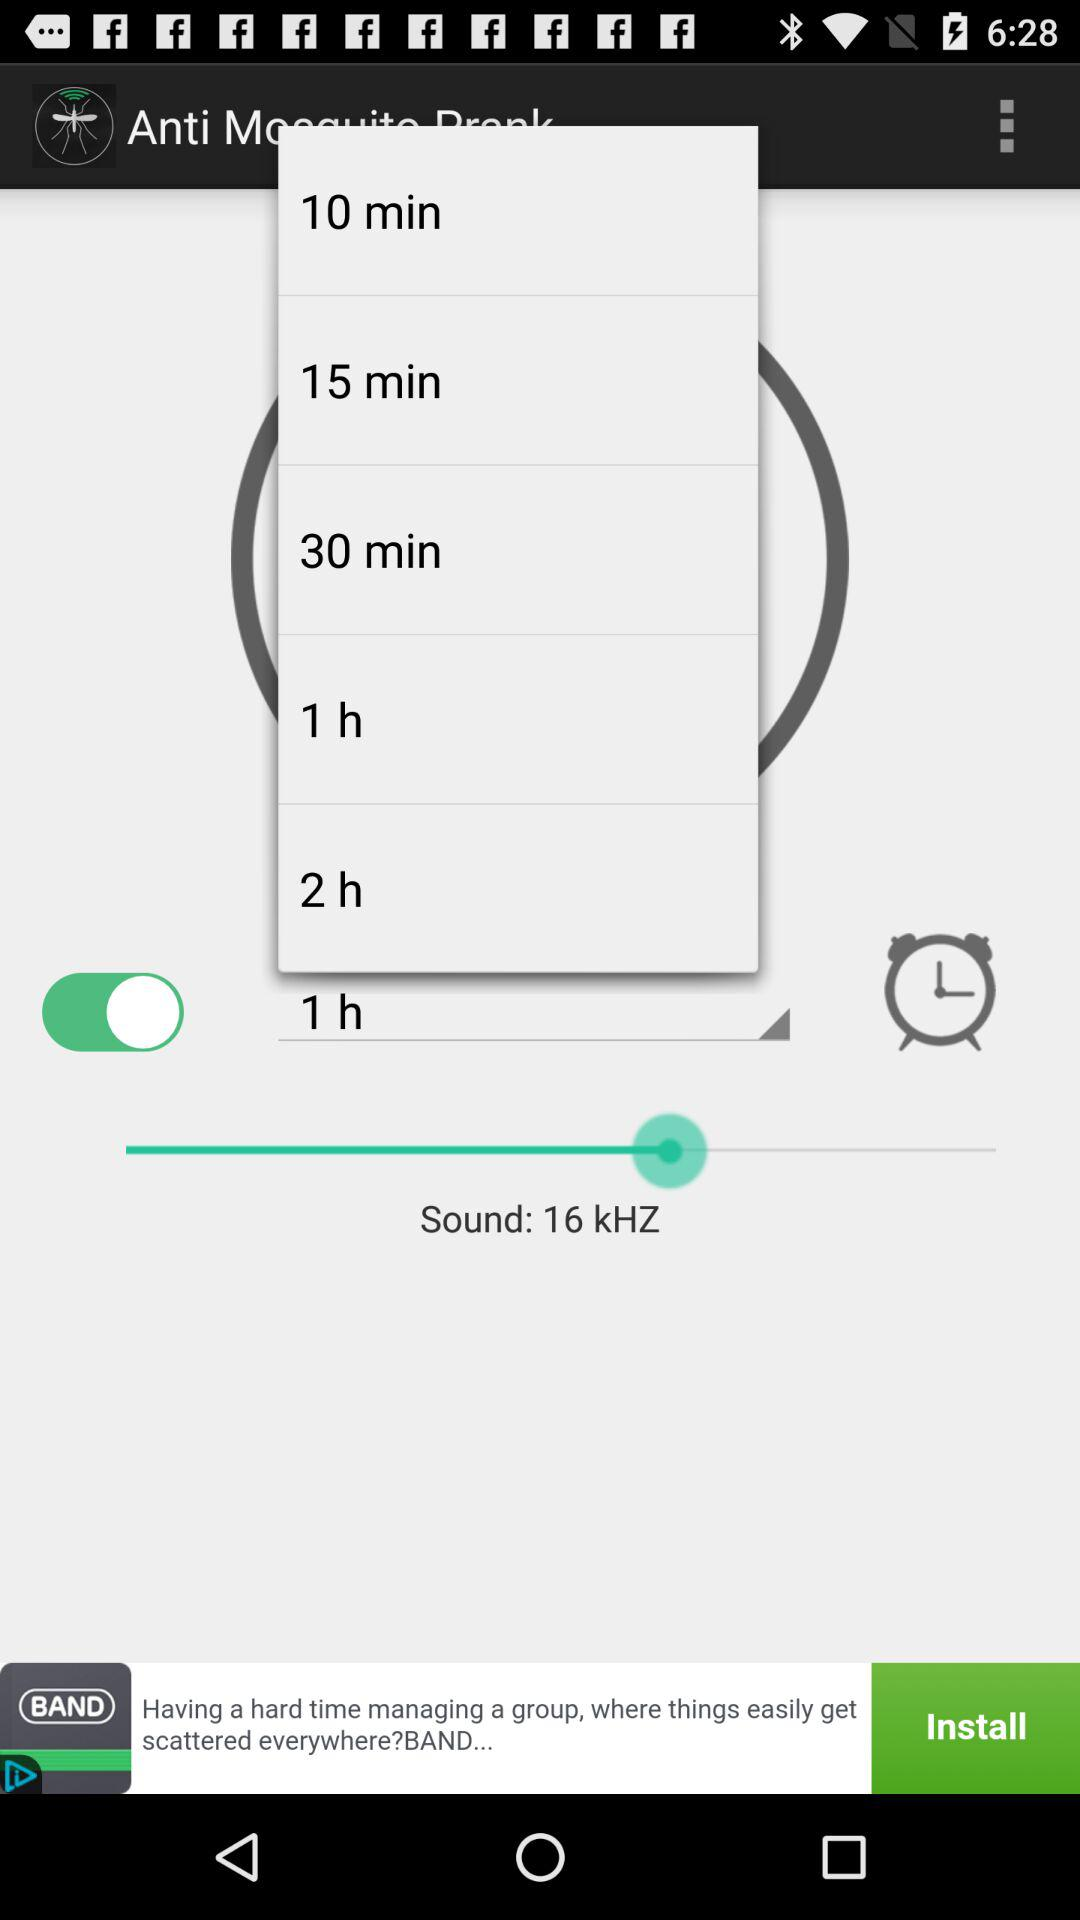What is the sound frequency? The sound frequency is 16 kHZ. 